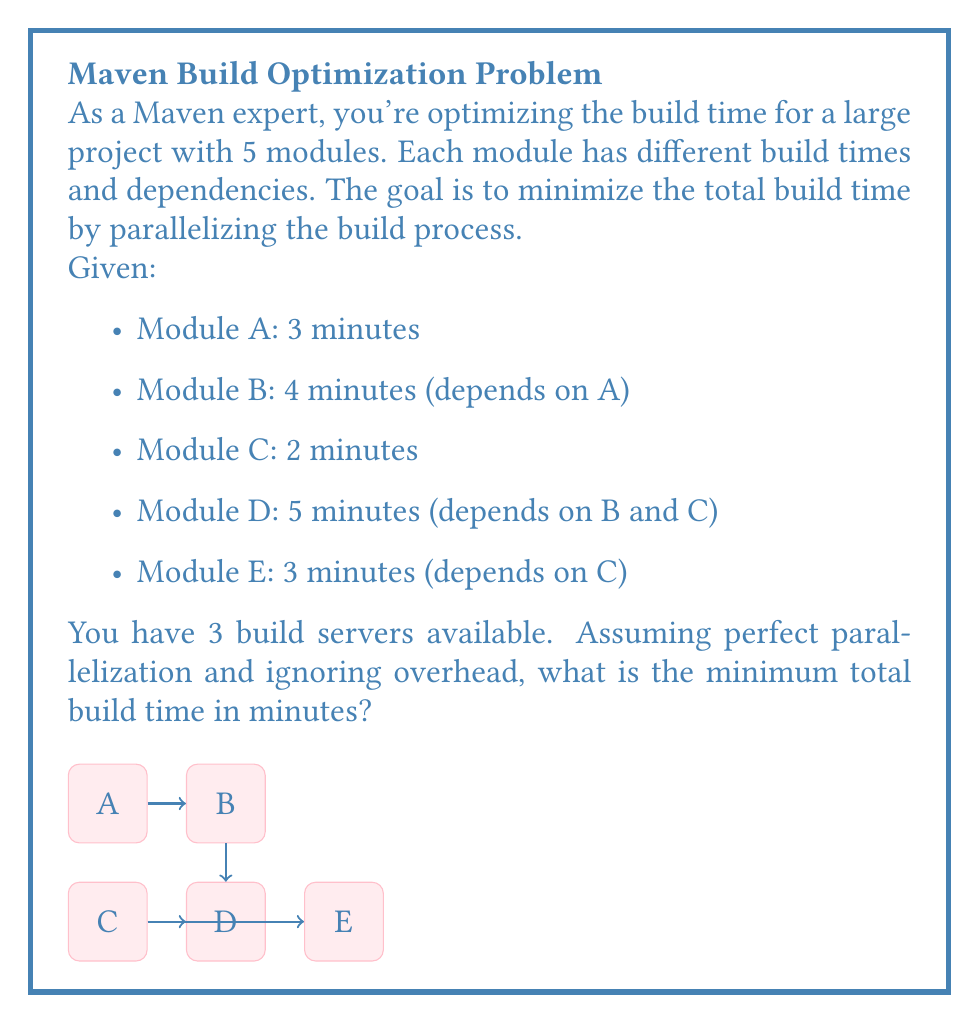What is the answer to this math problem? To solve this optimization problem using linear programming, we need to consider the dependencies and parallelization possibilities:

1. First, let's identify the critical path and parallel execution opportunities:
   - A must be built first (3 min)
   - B depends on A (4 min after A)
   - C can be built in parallel with A (2 min)
   - D depends on both B and C (5 min after both B and C are done)
   - E depends only on C (3 min after C)

2. We can represent this as a linear programming problem:
   Let $t$ be the total build time we want to minimize.
   Let $x_A, x_B, x_C, x_D, x_E$ be the start times for each module.

3. Objective function:
   Minimize $t$

4. Constraints:
   $$x_A + 3 \leq t$$
   $$x_B + 4 \leq t$$
   $$x_C + 2 \leq t$$
   $$x_D + 5 \leq t$$
   $$x_E + 3 \leq t$$
   $$x_A + 3 \leq x_B$$ (B depends on A)
   $$x_B + 4 \leq x_D$$ (D depends on B)
   $$x_C + 2 \leq x_D$$ (D depends on C)
   $$x_C + 2 \leq x_E$$ (E depends on C)
   $$x_A, x_B, x_C, x_D, x_E \geq 0$$

5. Optimal solution:
   - Start A at t=0, finishes at t=3
   - Start C at t=0 (in parallel with A), finishes at t=2
   - Start B at t=3 (after A), finishes at t=7
   - Start E at t=2 (after C), finishes at t=5
   - Start D at t=7 (after B and C), finishes at t=12

6. The minimum total build time is determined by the latest finishing module, which is D at t=12.

Therefore, the minimum total build time is 12 minutes.
Answer: 12 minutes 